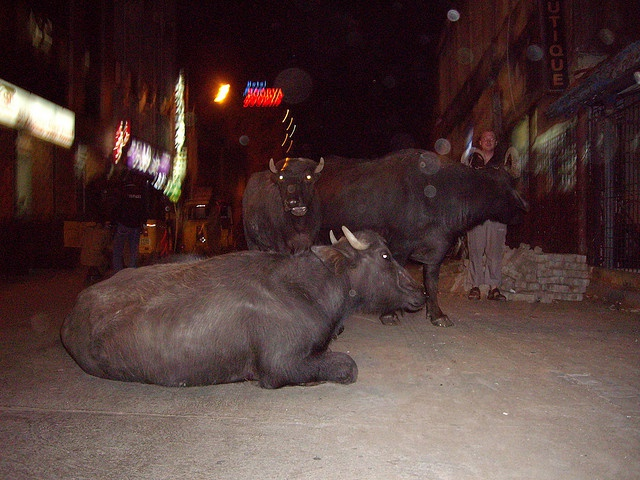Describe the objects in this image and their specific colors. I can see cow in black, gray, and maroon tones, cow in black, maroon, gray, and purple tones, cow in black, maroon, and brown tones, people in black, brown, maroon, and purple tones, and people in black, maroon, and purple tones in this image. 